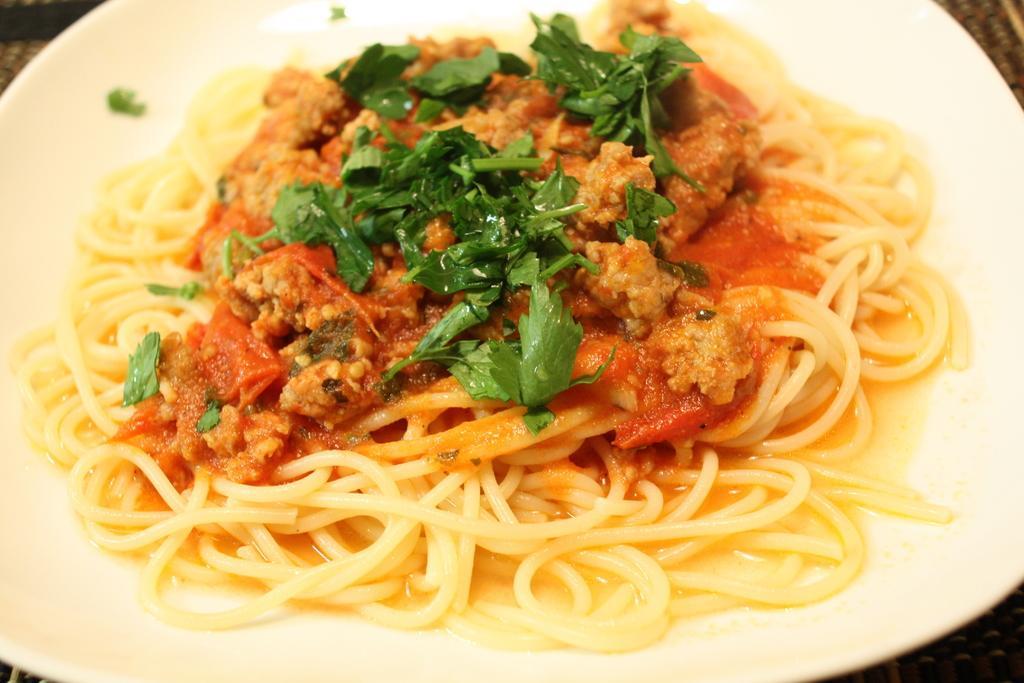Describe this image in one or two sentences. In this image we can see some food in a plate topped with some coriander leaves. 